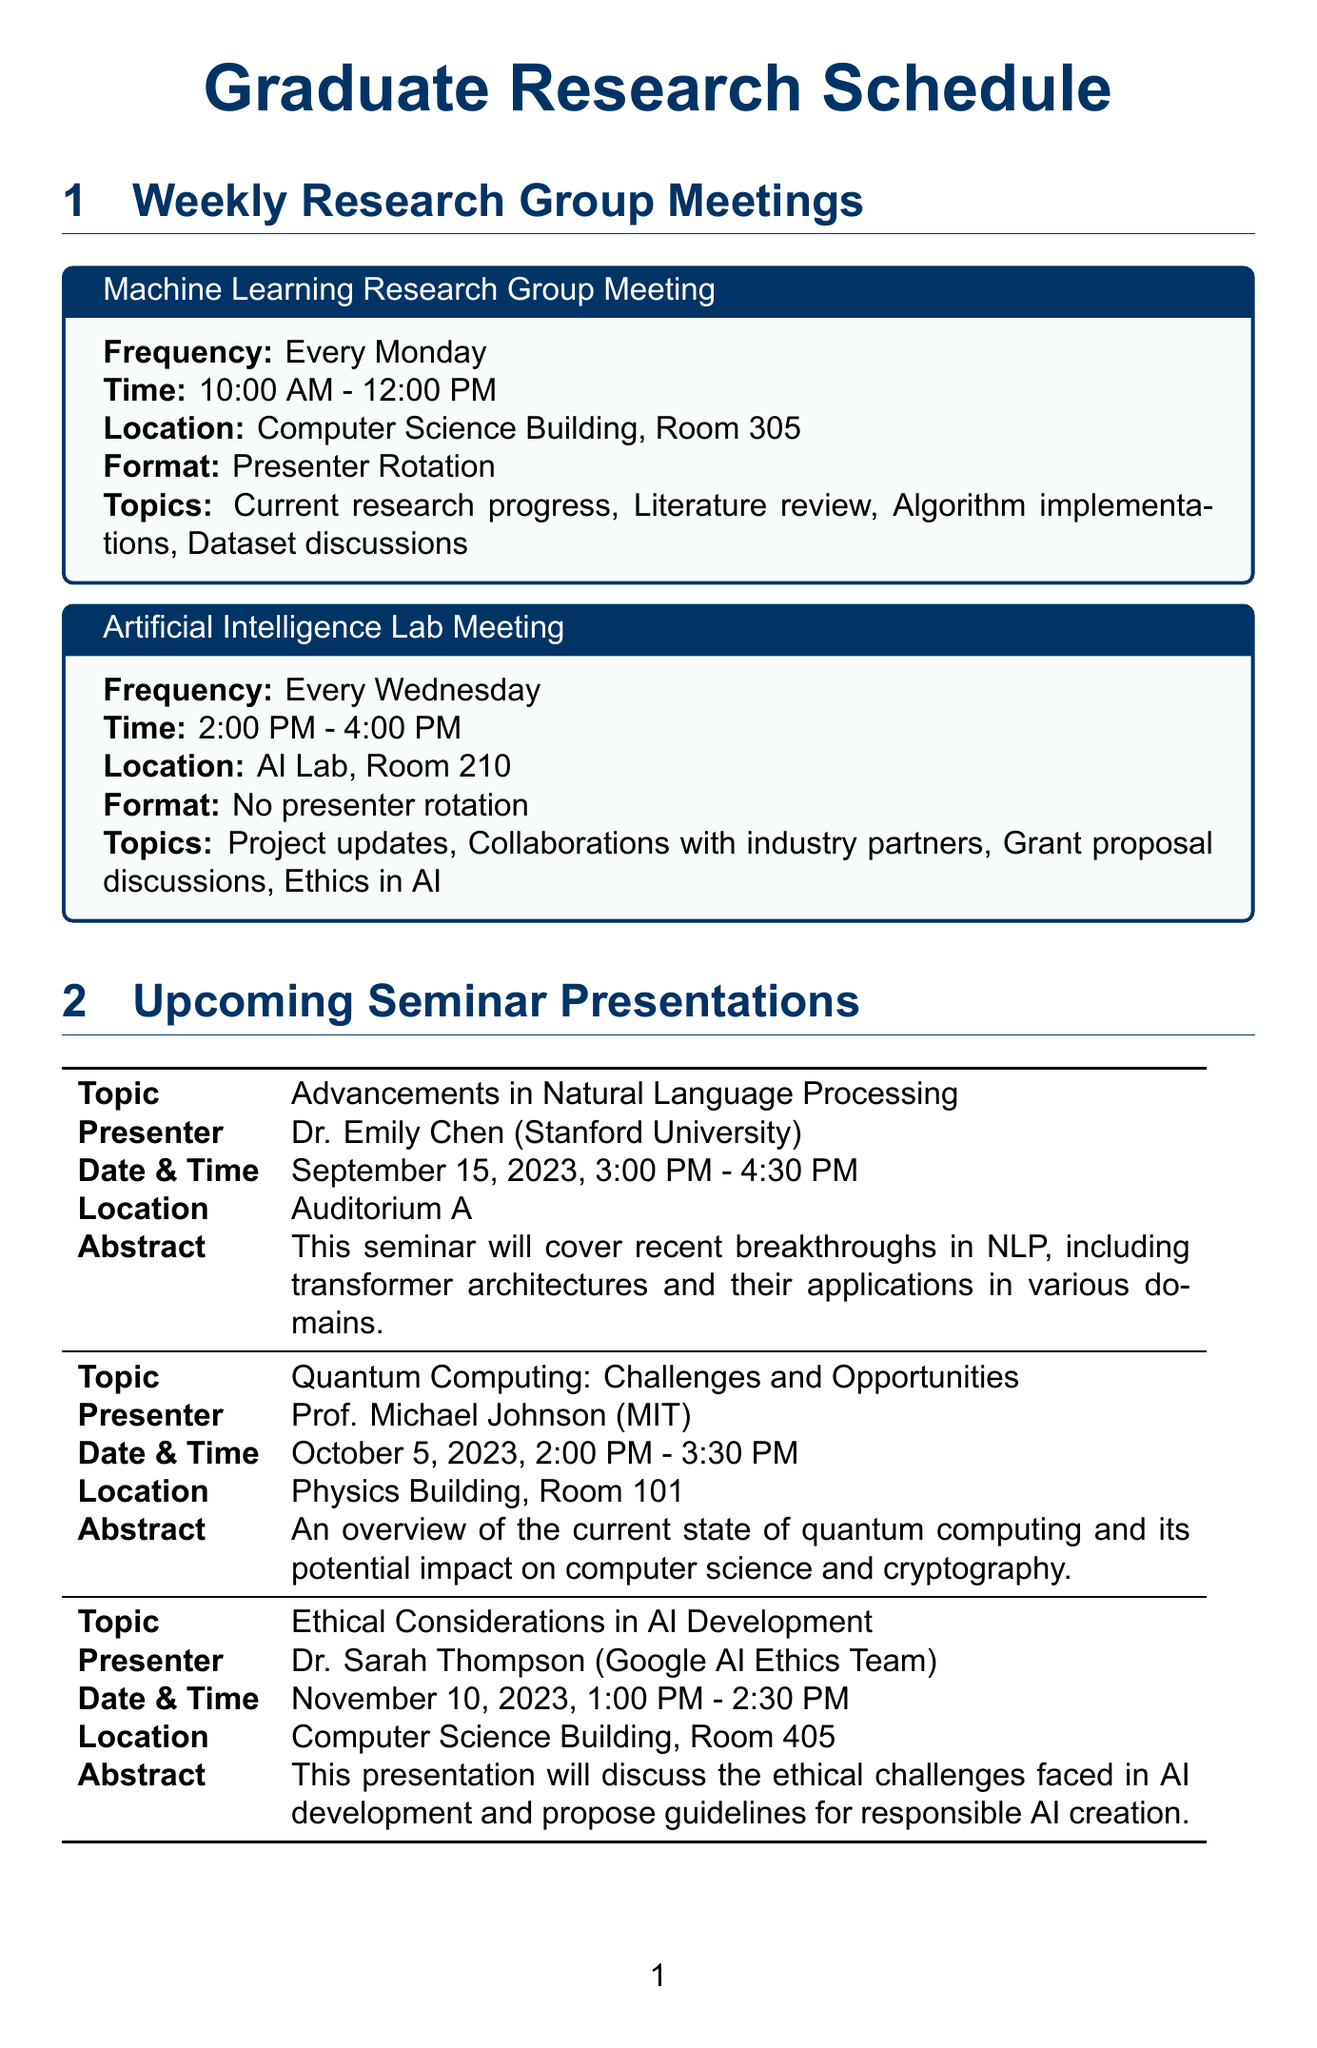What is the frequency of the Machine Learning Research Group Meeting? The frequency of the meeting is stated in the document.
Answer: Every Monday What location is the Artificial Intelligence Lab Meeting held in? The location for the meeting is listed in the document.
Answer: AI Lab, Room 210 Who is the presenter for the seminar on Ethical Considerations in AI Development? The presenter's name is given in the seminar details in the document.
Answer: Dr. Sarah Thompson What is the date for the TensorFlow Advanced Techniques workshop? The date of the workshop is directly mentioned in the document.
Answer: October 20, 2023 What time do the weekly research meetings take place? The document provides specific times for the meetings.
Answer: 10:00 AM - 12:00 PM Which topic relates to project updates at the AI Lab Meeting? One of the topics discussed in the AI Lab Meeting is listed in the document.
Answer: Project updates How many upcoming seminar presentations are listed in the document? The document enumerates the number of seminar presentations.
Answer: Three What is the deadline for ICML 2024 conference submissions? The specific deadline is provided in the conference section of the document.
Answer: January 26, 2024 Which instructor is leading the workshop on Scientific Writing for Computer Scientists? The document specifies who is instructing the workshop.
Answer: Prof. Lisa Wong 